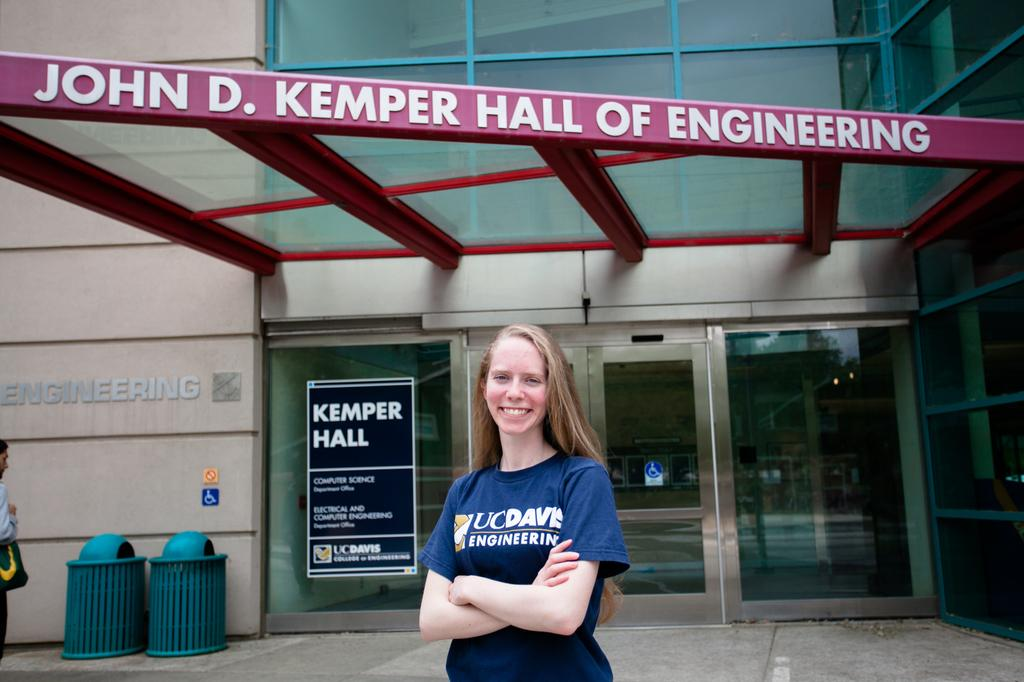<image>
Render a clear and concise summary of the photo. A woman standing in front of John D. Kemper Hall of Engineering. 